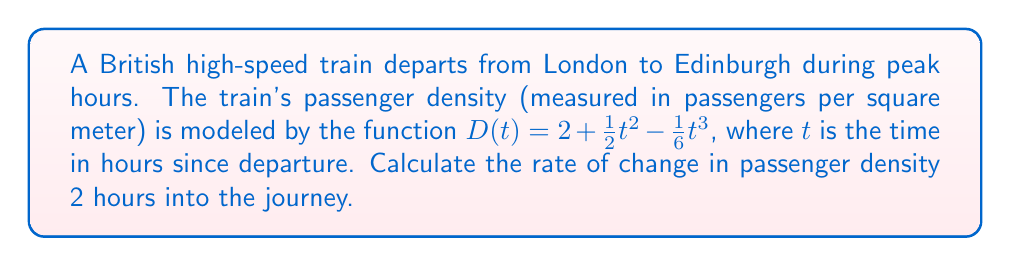Give your solution to this math problem. To solve this problem, we need to find the derivative of the passenger density function $D(t)$ and evaluate it at $t = 2$ hours. This will give us the instantaneous rate of change in passenger density at that time.

1. Given function: $D(t) = 2 + \frac{1}{2}t^2 - \frac{1}{6}t^3$

2. To find the rate of change, we need to differentiate $D(t)$ with respect to $t$:

   $$\frac{dD}{dt} = \frac{d}{dt}(2) + \frac{d}{dt}(\frac{1}{2}t^2) - \frac{d}{dt}(\frac{1}{6}t^3)$$

3. Applying differentiation rules:
   - The derivative of a constant is 0
   - The derivative of $t^2$ is $2t$
   - The derivative of $t^3$ is $3t^2$

   $$\frac{dD}{dt} = 0 + \frac{1}{2}(2t) - \frac{1}{6}(3t^2)$$

4. Simplify:
   $$\frac{dD}{dt} = t - \frac{1}{2}t^2$$

5. Now, we need to evaluate this at $t = 2$:
   $$\frac{dD}{dt}\bigg|_{t=2} = 2 - \frac{1}{2}(2^2) = 2 - 2 = 0$$

Therefore, the rate of change in passenger density 2 hours into the journey is 0 passengers per square meter per hour.
Answer: 0 passengers per square meter per hour 